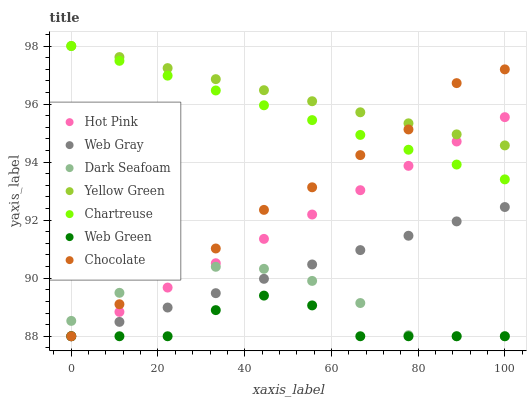Does Web Green have the minimum area under the curve?
Answer yes or no. Yes. Does Yellow Green have the maximum area under the curve?
Answer yes or no. Yes. Does Hot Pink have the minimum area under the curve?
Answer yes or no. No. Does Hot Pink have the maximum area under the curve?
Answer yes or no. No. Is Hot Pink the smoothest?
Answer yes or no. Yes. Is Chocolate the roughest?
Answer yes or no. Yes. Is Yellow Green the smoothest?
Answer yes or no. No. Is Yellow Green the roughest?
Answer yes or no. No. Does Web Gray have the lowest value?
Answer yes or no. Yes. Does Yellow Green have the lowest value?
Answer yes or no. No. Does Chartreuse have the highest value?
Answer yes or no. Yes. Does Hot Pink have the highest value?
Answer yes or no. No. Is Dark Seafoam less than Yellow Green?
Answer yes or no. Yes. Is Yellow Green greater than Web Gray?
Answer yes or no. Yes. Does Hot Pink intersect Chartreuse?
Answer yes or no. Yes. Is Hot Pink less than Chartreuse?
Answer yes or no. No. Is Hot Pink greater than Chartreuse?
Answer yes or no. No. Does Dark Seafoam intersect Yellow Green?
Answer yes or no. No. 